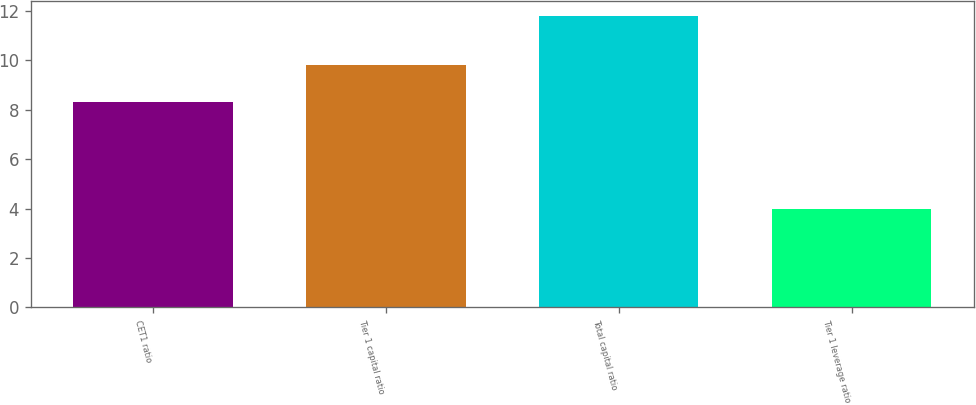Convert chart. <chart><loc_0><loc_0><loc_500><loc_500><bar_chart><fcel>CET1 ratio<fcel>Tier 1 capital ratio<fcel>Total capital ratio<fcel>Tier 1 leverage ratio<nl><fcel>8.3<fcel>9.8<fcel>11.8<fcel>4<nl></chart> 